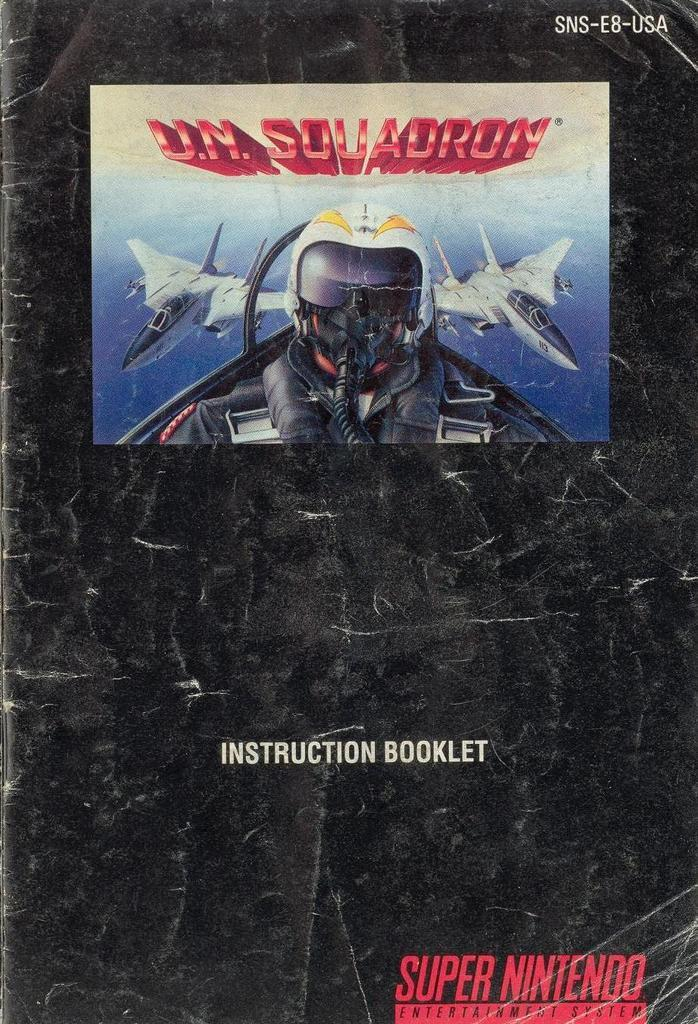<image>
Present a compact description of the photo's key features. A super nintendo instruction manual for the game U.N. Squadron. 